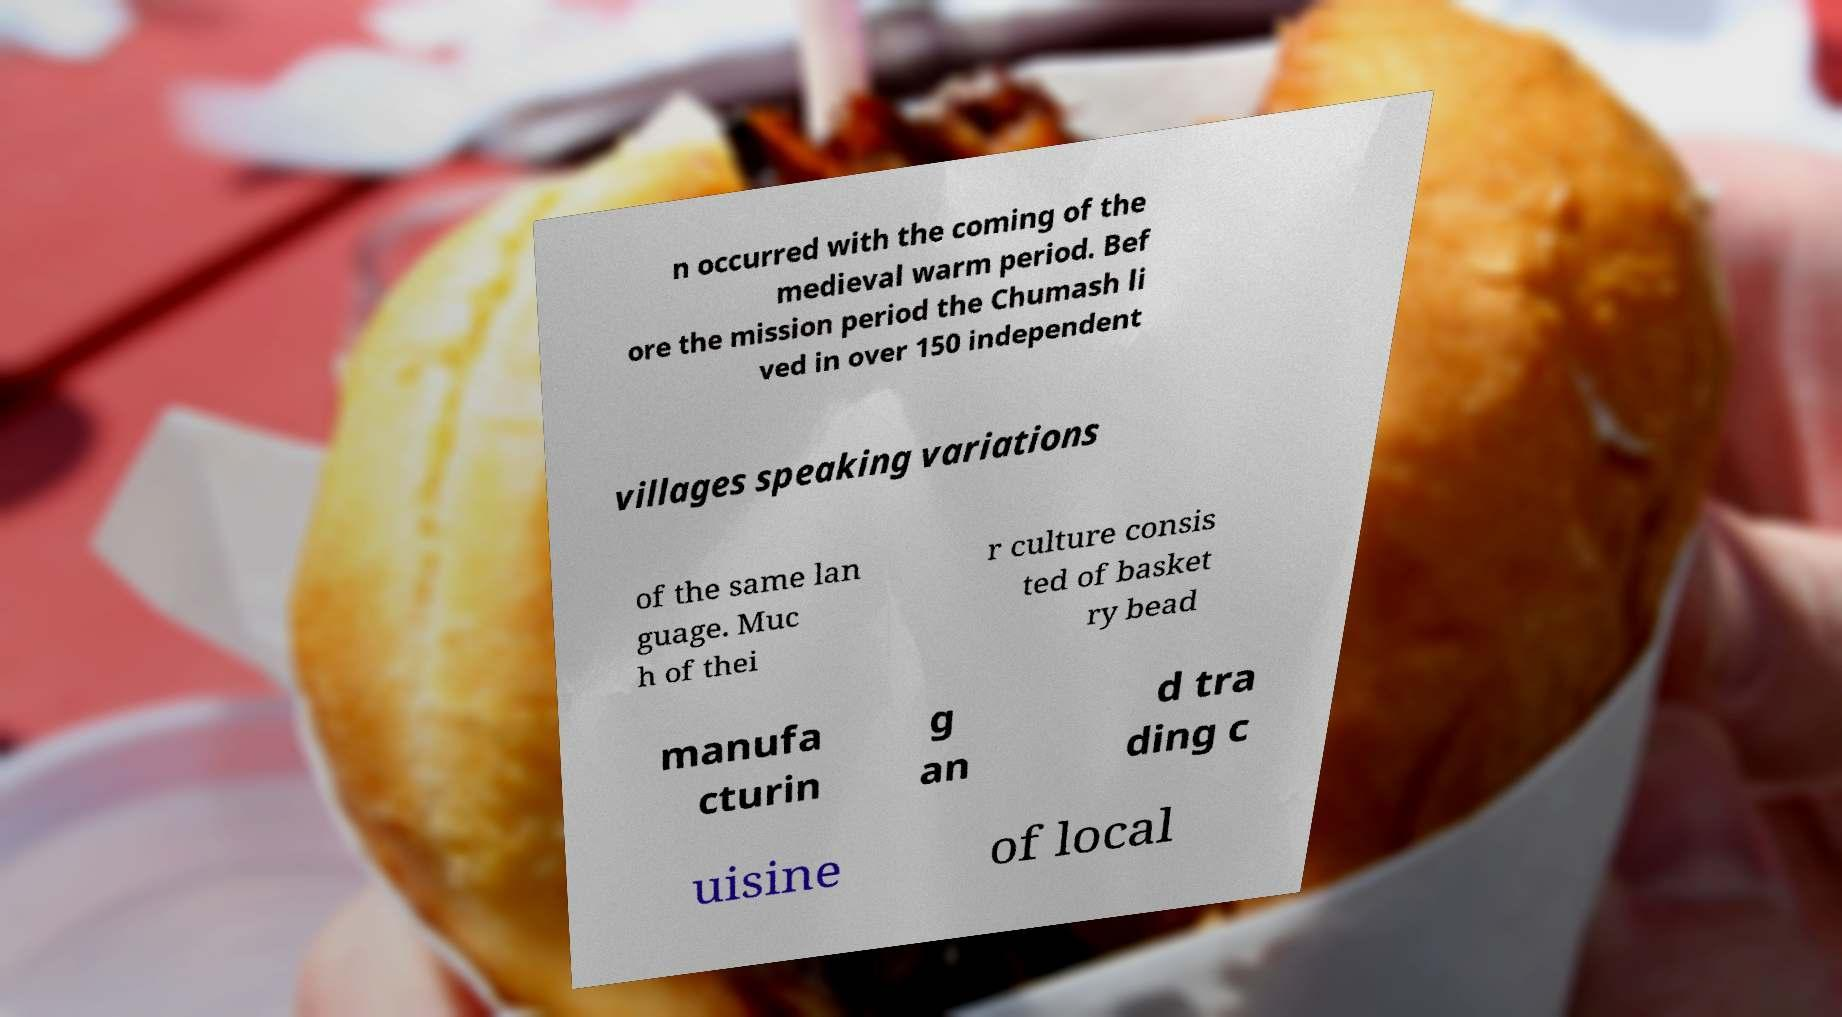Can you accurately transcribe the text from the provided image for me? n occurred with the coming of the medieval warm period. Bef ore the mission period the Chumash li ved in over 150 independent villages speaking variations of the same lan guage. Muc h of thei r culture consis ted of basket ry bead manufa cturin g an d tra ding c uisine of local 